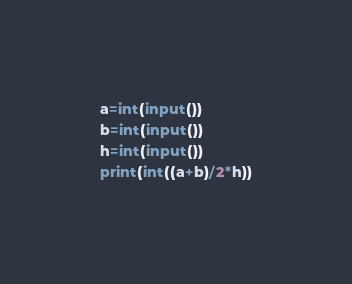Convert code to text. <code><loc_0><loc_0><loc_500><loc_500><_Python_>a=int(input())
b=int(input())
h=int(input())
print(int((a+b)/2*h))
</code> 